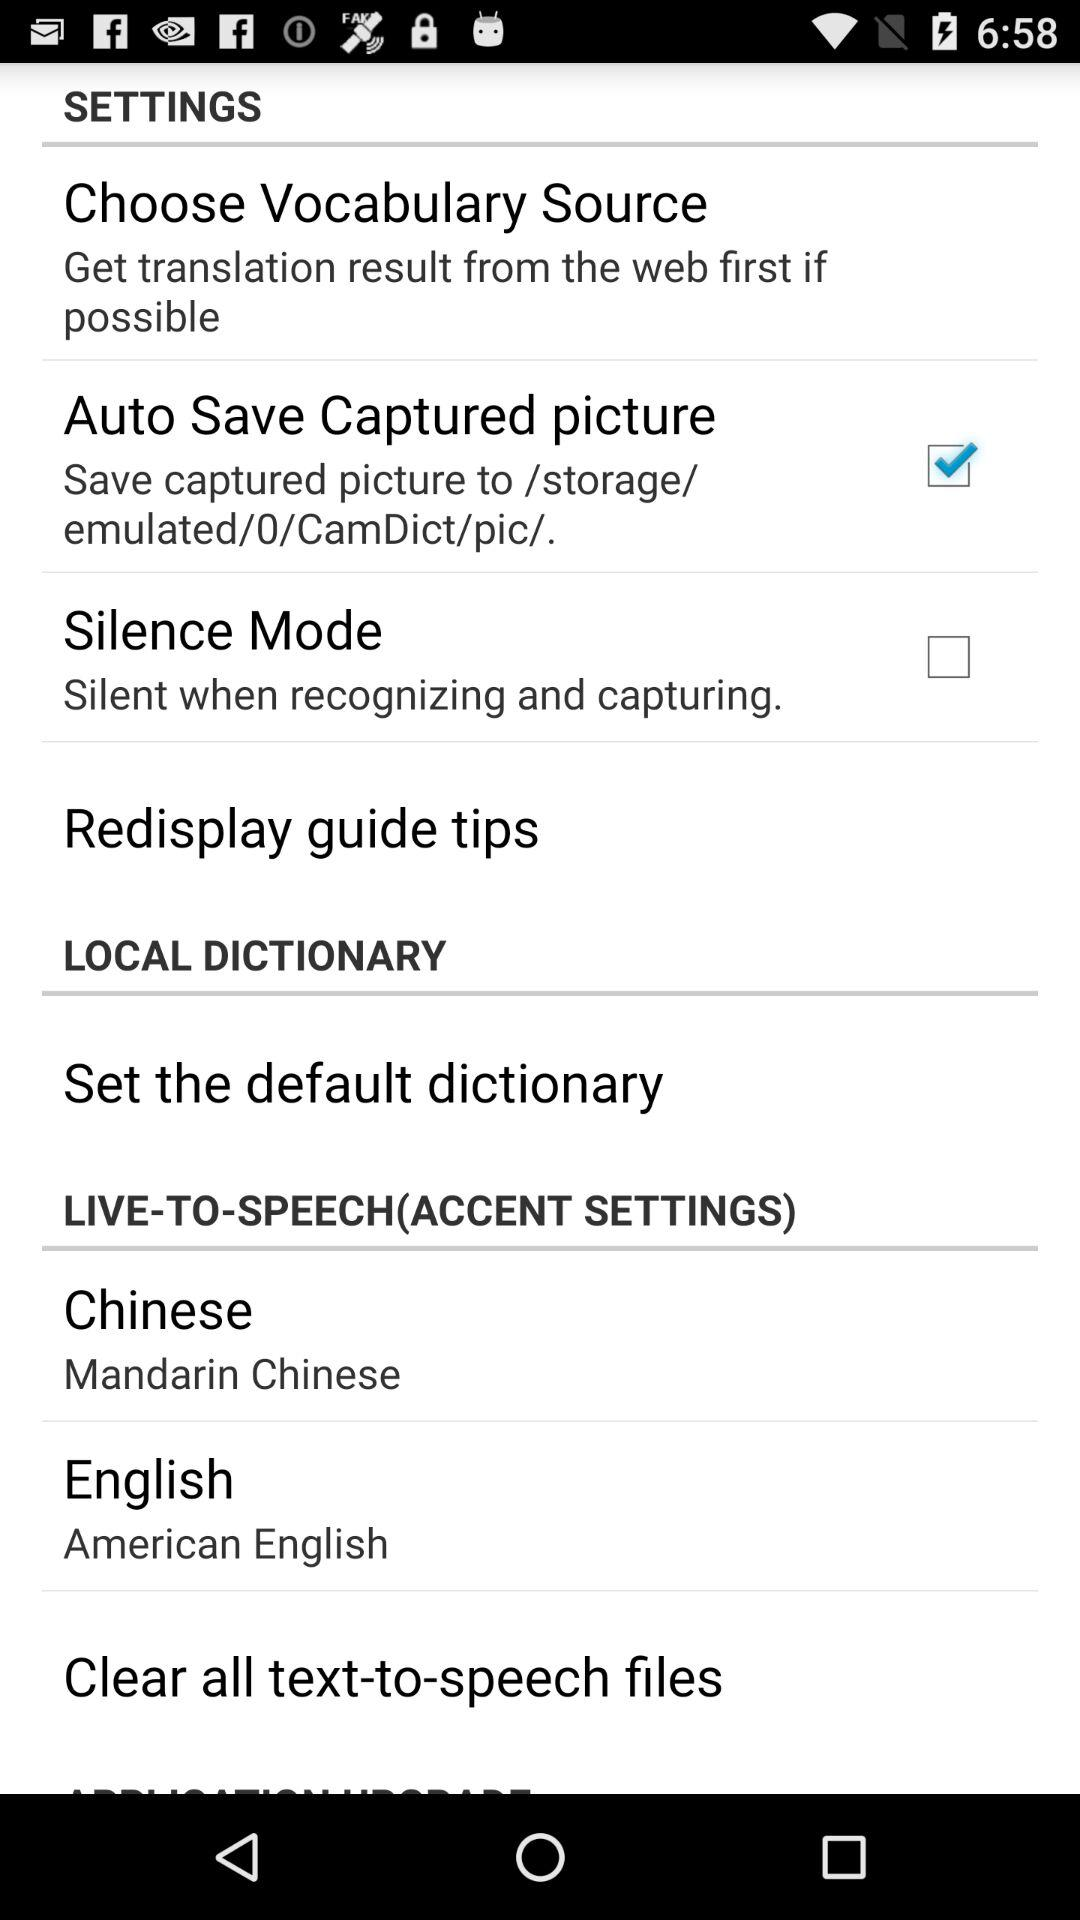Which English accent is selected? The selected English accent is American English. 